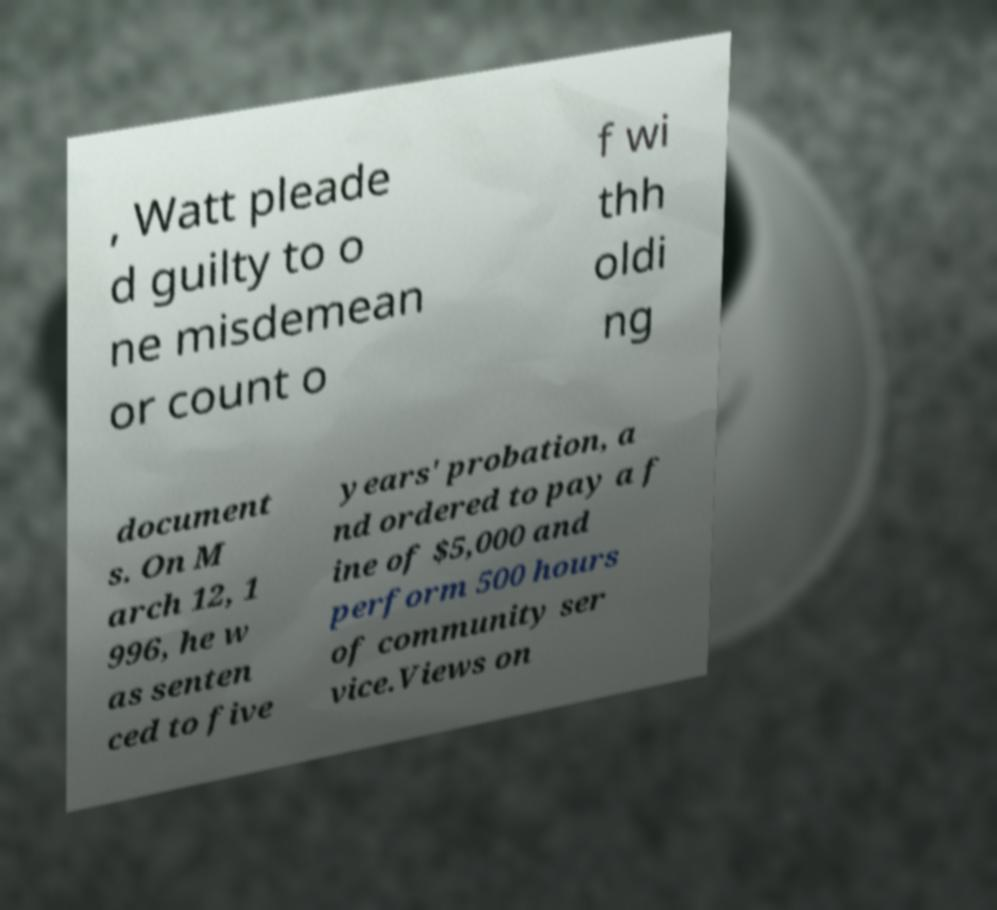Can you read and provide the text displayed in the image?This photo seems to have some interesting text. Can you extract and type it out for me? , Watt pleade d guilty to o ne misdemean or count o f wi thh oldi ng document s. On M arch 12, 1 996, he w as senten ced to five years' probation, a nd ordered to pay a f ine of $5,000 and perform 500 hours of community ser vice.Views on 